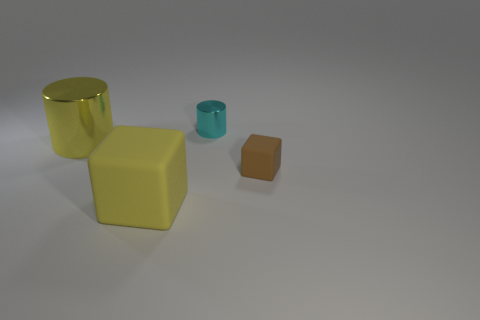Add 4 big yellow matte cubes. How many objects exist? 8 Add 4 cyan shiny cylinders. How many cyan shiny cylinders are left? 5 Add 3 big rubber objects. How many big rubber objects exist? 4 Subtract 0 gray blocks. How many objects are left? 4 Subtract all large brown rubber cubes. Subtract all tiny cyan cylinders. How many objects are left? 3 